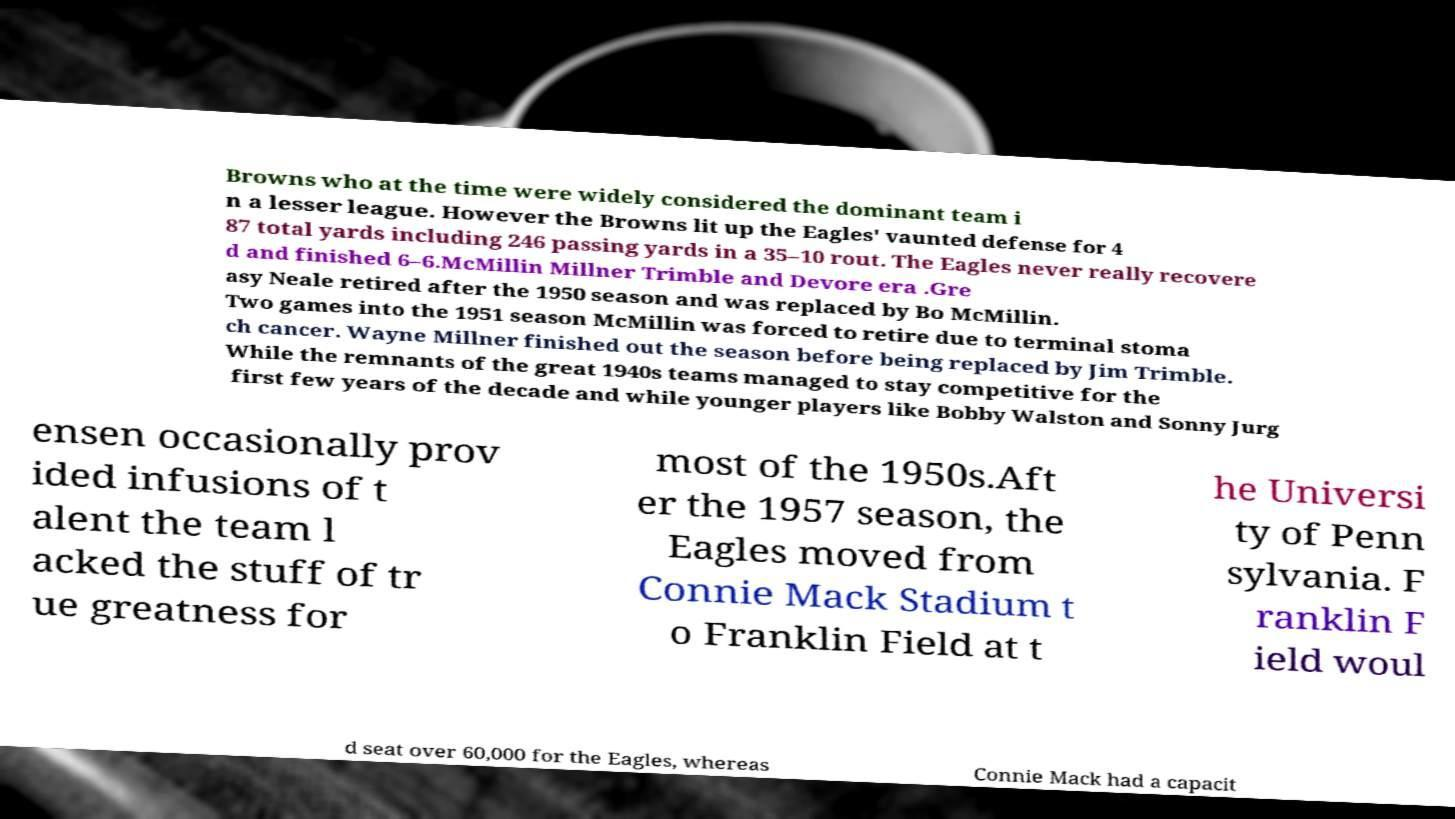Please identify and transcribe the text found in this image. Browns who at the time were widely considered the dominant team i n a lesser league. However the Browns lit up the Eagles' vaunted defense for 4 87 total yards including 246 passing yards in a 35–10 rout. The Eagles never really recovere d and finished 6–6.McMillin Millner Trimble and Devore era .Gre asy Neale retired after the 1950 season and was replaced by Bo McMillin. Two games into the 1951 season McMillin was forced to retire due to terminal stoma ch cancer. Wayne Millner finished out the season before being replaced by Jim Trimble. While the remnants of the great 1940s teams managed to stay competitive for the first few years of the decade and while younger players like Bobby Walston and Sonny Jurg ensen occasionally prov ided infusions of t alent the team l acked the stuff of tr ue greatness for most of the 1950s.Aft er the 1957 season, the Eagles moved from Connie Mack Stadium t o Franklin Field at t he Universi ty of Penn sylvania. F ranklin F ield woul d seat over 60,000 for the Eagles, whereas Connie Mack had a capacit 